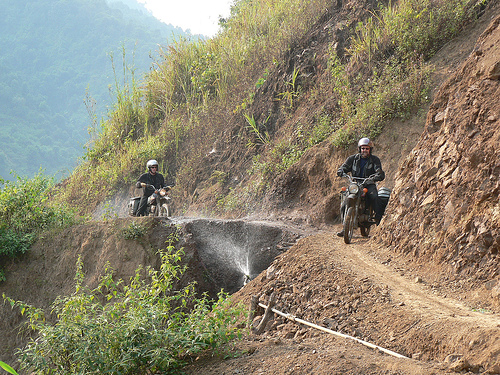What does the environment suggest about the potential difficulty of the motorbike journey? The environment, with its steep inclines and loose dirt paths, suggests a high level of difficulty for the motorbike journey. The riders must navigate a narrow trail flanked by a sharp drop on one side and a hill on the other, indicating a need for careful maneuvering and control in what appears to be a remote and challenging terrain. 